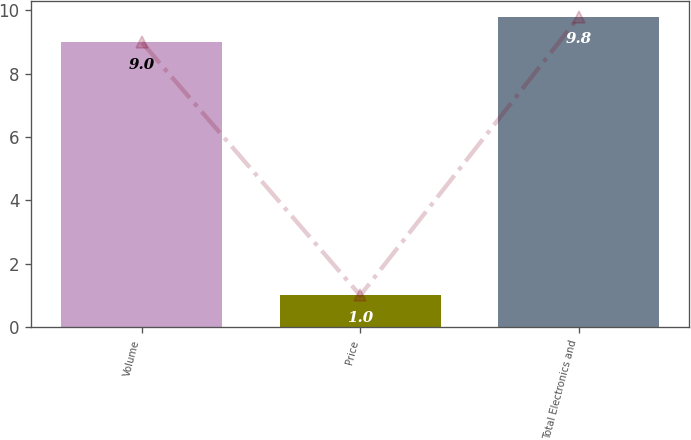Convert chart to OTSL. <chart><loc_0><loc_0><loc_500><loc_500><bar_chart><fcel>Volume<fcel>Price<fcel>Total Electronics and<nl><fcel>9<fcel>1<fcel>9.8<nl></chart> 